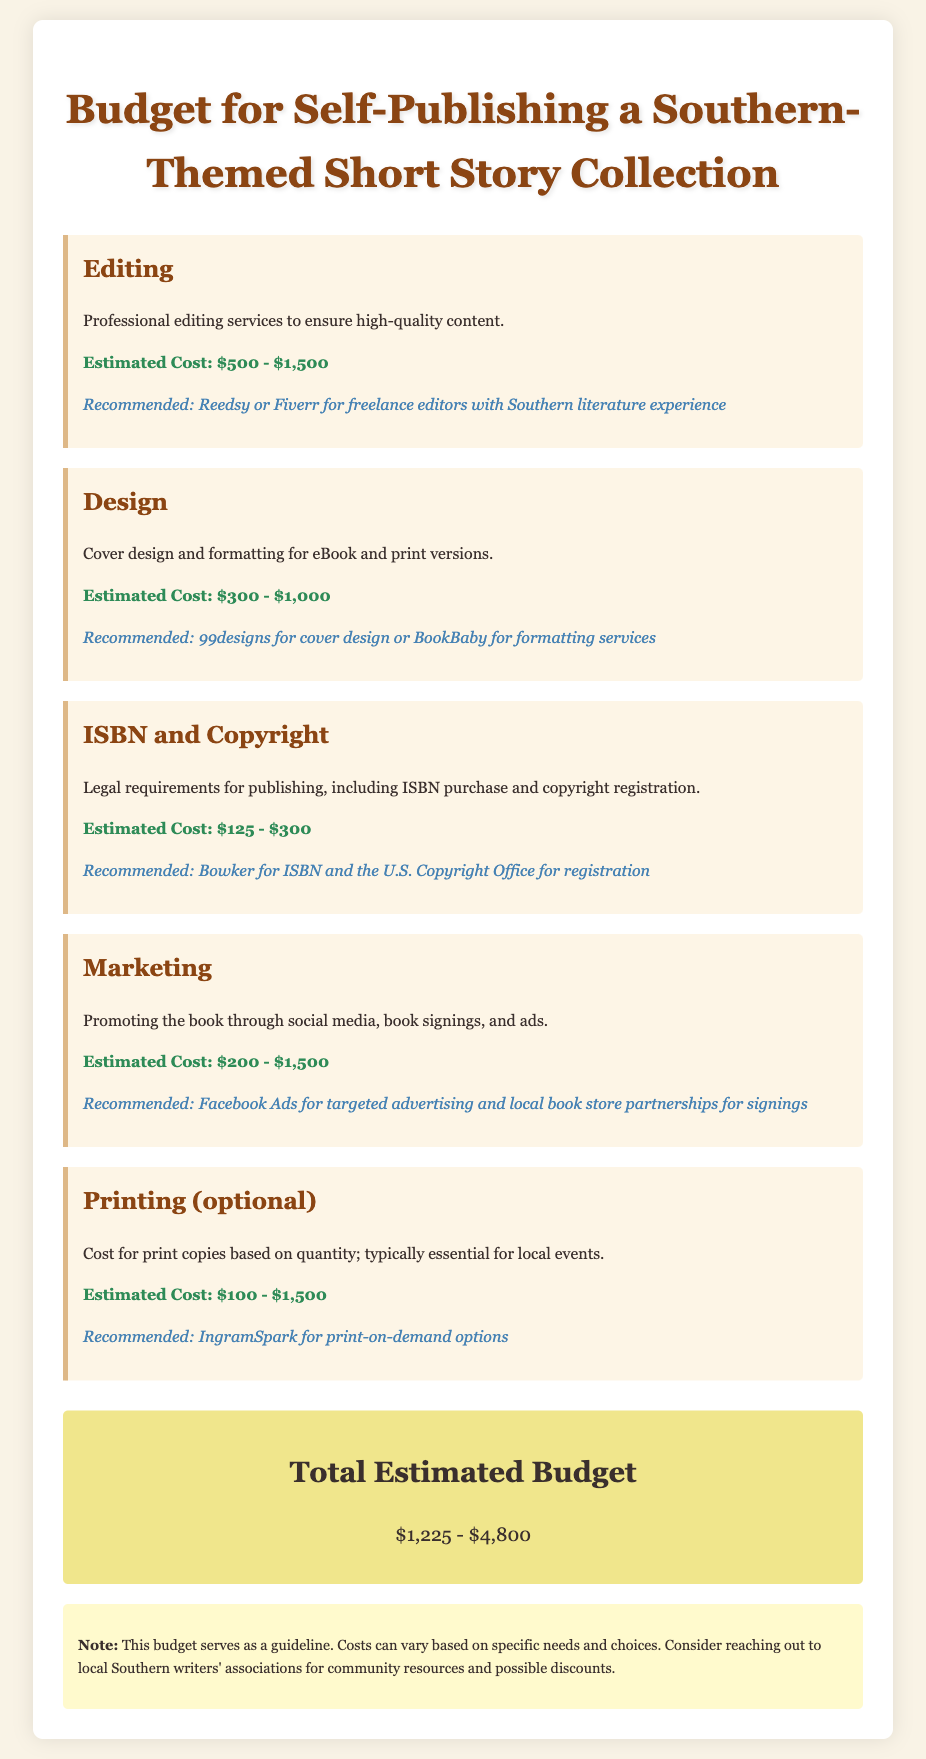What is the estimated cost range for editing? The document specifies the estimated cost range for editing services is between $500 and $1,500.
Answer: $500 - $1,500 What is the recommended service for cover design? The recommended service for cover design mentioned in the document is 99designs.
Answer: 99designs What is the estimated cost for ISBN and copyright? The document states the estimated cost for ISBN and copyright is between $125 and $300.
Answer: $125 - $300 What is the highest estimated cost for marketing? According to the document, the highest estimated cost for marketing is $1,500.
Answer: $1,500 What is the total estimated budget range? The document concludes with a total estimated budget range of $1,225 to $4,800.
Answer: $1,225 - $4,800 What is an optional cost mentioned in the budget? The document lists printing as an optional cost for the budget.
Answer: Printing Which organization is recommended for ISBN purchase? Bowker is the recommended organization mentioned for ISBN purchase in the document.
Answer: Bowker What type of legal requirements are outlined in the budget? The document outlines legal requirements for publishing, specifically for ISBN purchase and copyright registration.
Answer: ISBN purchase and copyright registration What type of advertising is recommended for marketing? The document recommends Facebook Ads for targeted advertising as a marketing strategy.
Answer: Facebook Ads 